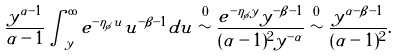Convert formula to latex. <formula><loc_0><loc_0><loc_500><loc_500>\frac { y ^ { \alpha - 1 } } { \alpha - 1 } \int _ { y } ^ { \infty } e ^ { - \eta _ { \phi } u } u ^ { - \beta - 1 } d u \stackrel { 0 } { \sim } \frac { e ^ { - \eta _ { \phi } y } y ^ { - \beta - 1 } } { ( \alpha - 1 ) ^ { 2 } y ^ { - \alpha } } \stackrel { 0 } { \sim } \frac { y ^ { \alpha - \beta - 1 } } { ( \alpha - 1 ) ^ { 2 } } .</formula> 